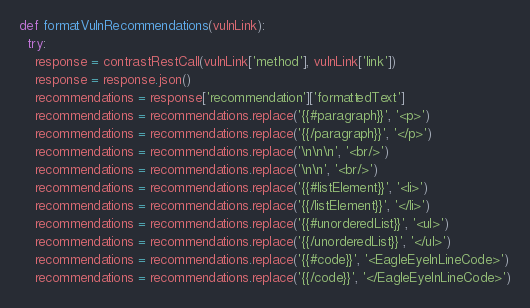<code> <loc_0><loc_0><loc_500><loc_500><_Python_>def formatVulnRecommendations(vulnLink):
  try:
    response = contrastRestCall(vulnLink['method'], vulnLink['link'])
    response = response.json()
    recommendations = response['recommendation']['formattedText']
    recommendations = recommendations.replace('{{#paragraph}}', '<p>')
    recommendations = recommendations.replace('{{/paragraph}}', '</p>')
    recommendations = recommendations.replace('\n\n\n', '<br/>')
    recommendations = recommendations.replace('\n\n', '<br/>')
    recommendations = recommendations.replace('{{#listElement}}', '<li>')
    recommendations = recommendations.replace('{{/listElement}}', '</li>')
    recommendations = recommendations.replace('{{#unorderedList}}', '<ul>')
    recommendations = recommendations.replace('{{/unorderedList}}', '</ul>')
    recommendations = recommendations.replace('{{#code}}', '<EagleEyeInLineCode>')
    recommendations = recommendations.replace('{{/code}}', '</EagleEyeInLineCode>')</code> 